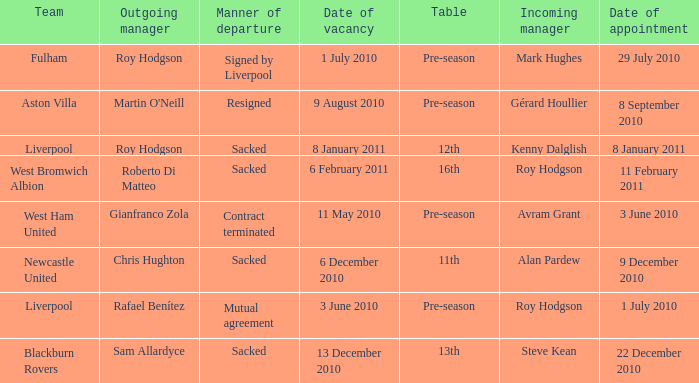What is the date of vacancy for the Liverpool team with a table named pre-season? 3 June 2010. 